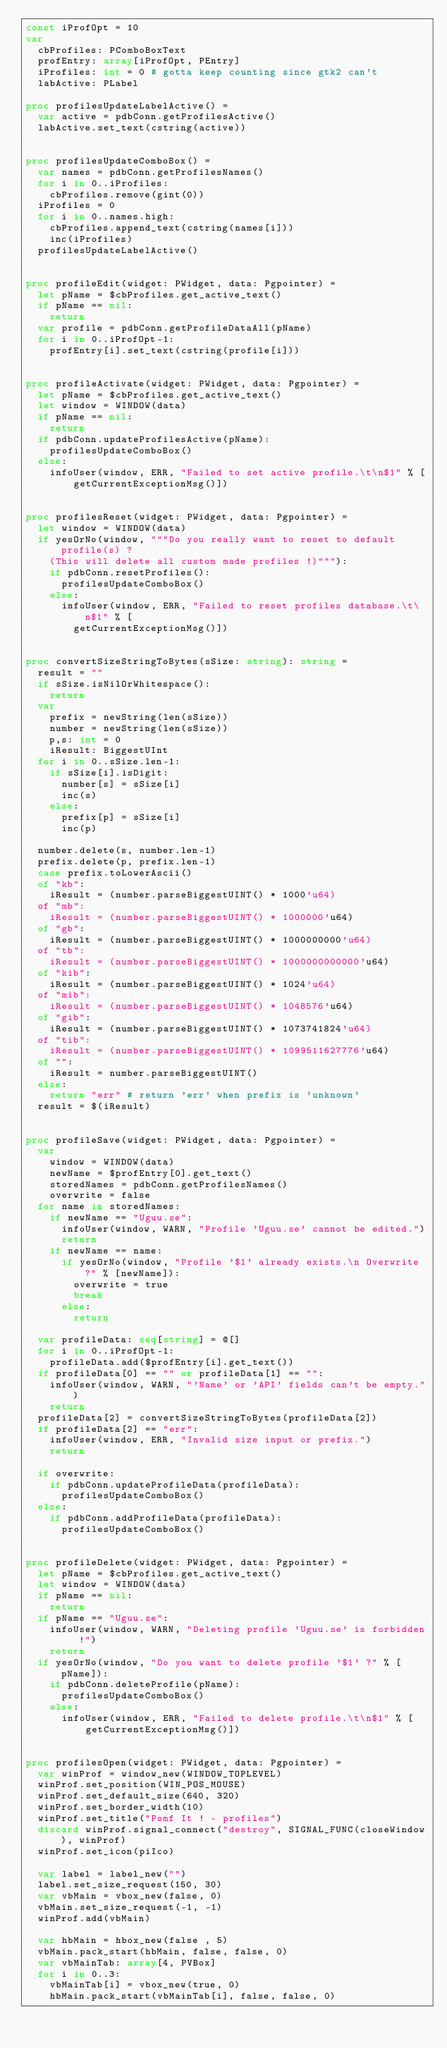Convert code to text. <code><loc_0><loc_0><loc_500><loc_500><_Nim_>const iProfOpt = 10
var
  cbProfiles: PComboBoxText
  profEntry: array[iProfOpt, PEntry]
  iProfiles: int = 0 # gotta keep counting since gtk2 can't
  labActive: PLabel

proc profilesUpdateLabelActive() =
  var active = pdbConn.getProfilesActive()
  labActive.set_text(cstring(active))


proc profilesUpdateComboBox() =
  var names = pdbConn.getProfilesNames()
  for i in 0..iProfiles:
    cbProfiles.remove(gint(0))
  iProfiles = 0
  for i in 0..names.high:
    cbProfiles.append_text(cstring(names[i]))
    inc(iProfiles)
  profilesUpdateLabelActive()


proc profileEdit(widget: PWidget, data: Pgpointer) =
  let pName = $cbProfiles.get_active_text()
  if pName == nil:
    return
  var profile = pdbConn.getProfileDataAll(pName)
  for i in 0..iProfOpt-1:
    profEntry[i].set_text(cstring(profile[i]))


proc profileActivate(widget: PWidget, data: Pgpointer) =
  let pName = $cbProfiles.get_active_text()
  let window = WINDOW(data)
  if pName == nil:
    return  
  if pdbConn.updateProfilesActive(pName):
    profilesUpdateComboBox()
  else:
    infoUser(window, ERR, "Failed to set active profile.\t\n$1" % [
        getCurrentExceptionMsg()])


proc profilesReset(widget: PWidget, data: Pgpointer) =
  let window = WINDOW(data)
  if yesOrNo(window, """Do you really want to reset to default profile(s) ?
    (This will delete all custom made profiles !)"""):
    if pdbConn.resetProfiles():
      profilesUpdateComboBox()
    else:
      infoUser(window, ERR, "Failed to reset profiles database.\t\n$1" % [
        getCurrentExceptionMsg()])
      

proc convertSizeStringToBytes(sSize: string): string =
  result = ""
  if sSize.isNilOrWhitespace():
    return
  var
    prefix = newString(len(sSize))
    number = newString(len(sSize))
    p,s: int = 0
    iResult: BiggestUInt
  for i in 0..sSize.len-1:
    if sSize[i].isDigit:
      number[s] = sSize[i]
      inc(s)
    else:
      prefix[p] = sSize[i]
      inc(p)
  
  number.delete(s, number.len-1)
  prefix.delete(p, prefix.len-1)
  case prefix.toLowerAscii()
  of "kb":
    iResult = (number.parseBiggestUINT() * 1000'u64)
  of "mb":
    iResult = (number.parseBiggestUINT() * 1000000'u64)
  of "gb":
    iResult = (number.parseBiggestUINT() * 1000000000'u64)
  of "tb":
    iResult = (number.parseBiggestUINT() * 1000000000000'u64)
  of "kib":
    iResult = (number.parseBiggestUINT() * 1024'u64)
  of "mib":
    iResult = (number.parseBiggestUINT() * 1048576'u64)
  of "gib":
    iResult = (number.parseBiggestUINT() * 1073741824'u64)
  of "tib":
    iResult = (number.parseBiggestUINT() * 1099511627776'u64)
  of "":
    iResult = number.parseBiggestUINT()
  else:
    return "err" # return 'err' when prefix is 'unknown'
  result = $(iResult)


proc profileSave(widget: PWidget, data: Pgpointer) =
  var
    window = WINDOW(data)
    newName = $profEntry[0].get_text()
    storedNames = pdbConn.getProfilesNames()
    overwrite = false
  for name in storedNames:
    if newName == "Uguu.se":
      infoUser(window, WARN, "Profile 'Uguu.se' cannot be edited.")
      return
    if newName == name:
      if yesOrNo(window, "Profile '$1' already exists.\n Overwrite ?" % [newName]):
        overwrite = true
        break
      else:
        return

  var profileData: seq[string] = @[]
  for i in 0..iProfOpt-1:
    profileData.add($profEntry[i].get_text())
  if profileData[0] == "" or profileData[1] == "":
    infoUser(window, WARN, "'Name' or 'API' fields can't be empty.")
    return
  profileData[2] = convertSizeStringToBytes(profileData[2])
  if profileData[2] == "err":
    infoUser(window, ERR, "Invalid size input or prefix.")
    return
    
  if overwrite:
    if pdbConn.updateProfileData(profileData):
      profilesUpdateComboBox()
  else:
    if pdbConn.addProfileData(profileData):
      profilesUpdateComboBox()
  
  
proc profileDelete(widget: PWidget, data: Pgpointer) =
  let pName = $cbProfiles.get_active_text()
  let window = WINDOW(data)
  if pName == nil:
    return
  if pName == "Uguu.se":
    infoUser(window, WARN, "Deleting profile 'Uguu.se' is forbidden !")
    return
  if yesOrNo(window, "Do you want to delete profile '$1' ?" % [pName]):
    if pdbConn.deleteProfile(pName):
      profilesUpdateComboBox()
    else:
      infoUser(window, ERR, "Failed to delete profile.\t\n$1" % [
          getCurrentExceptionMsg()])
        

proc profilesOpen(widget: PWidget, data: Pgpointer) =
  var winProf = window_new(WINDOW_TOPLEVEL)
  winProf.set_position(WIN_POS_MOUSE)
  winProf.set_default_size(640, 320)
  winProf.set_border_width(10)
  winProf.set_title("Pomf It ! - profiles")
  discard winProf.signal_connect("destroy", SIGNAL_FUNC(closeWindow), winProf)
  winProf.set_icon(piIco)

  var label = label_new("")
  label.set_size_request(150, 30)
  var vbMain = vbox_new(false, 0)
  vbMain.set_size_request(-1, -1)
  winProf.add(vbMain)
  
  var hbMain = hbox_new(false , 5)
  vbMain.pack_start(hbMain, false, false, 0)
  var vbMainTab: array[4, PVBox]
  for i in 0..3:
    vbMainTab[i] = vbox_new(true, 0)
    hbMain.pack_start(vbMainTab[i], false, false, 0)
  </code> 